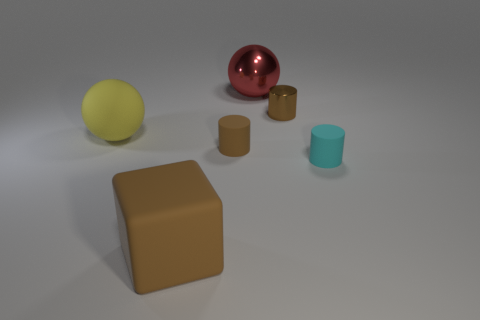Add 1 small metallic cylinders. How many objects exist? 7 Subtract all spheres. How many objects are left? 4 Subtract all tiny gray cylinders. Subtract all brown shiny things. How many objects are left? 5 Add 5 small brown metal things. How many small brown metal things are left? 6 Add 4 brown metal things. How many brown metal things exist? 5 Subtract 0 blue cylinders. How many objects are left? 6 